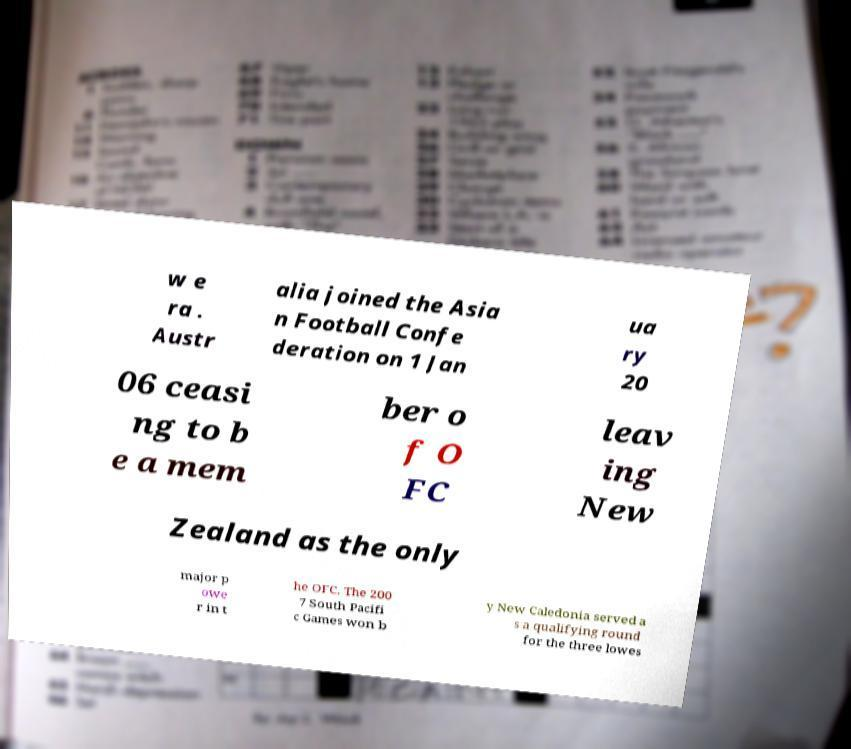I need the written content from this picture converted into text. Can you do that? w e ra . Austr alia joined the Asia n Football Confe deration on 1 Jan ua ry 20 06 ceasi ng to b e a mem ber o f O FC leav ing New Zealand as the only major p owe r in t he OFC. The 200 7 South Pacifi c Games won b y New Caledonia served a s a qualifying round for the three lowes 